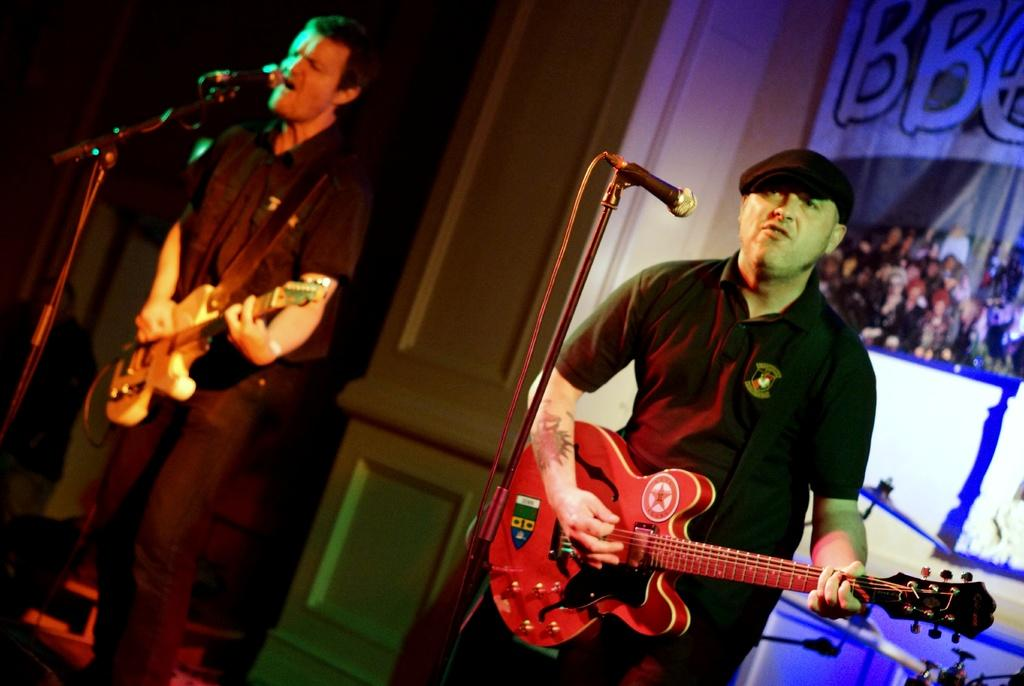How many people are in the image? There are two men in the image. What are the men holding in the image? The men are holding guitars. What are the men doing with the guitars? The men are playing the guitars. What else are the men doing in the image? The men are singing and using microphones. What can be seen in the background of the image? There is a wall, a banner, and drums in the background of the image. What type of stream can be seen flowing through the image? There is no stream present in the image; it features two men playing guitars, singing, and using microphones. Who is the representative of the band in the image? There is no indication of a band or a representative in the image. 